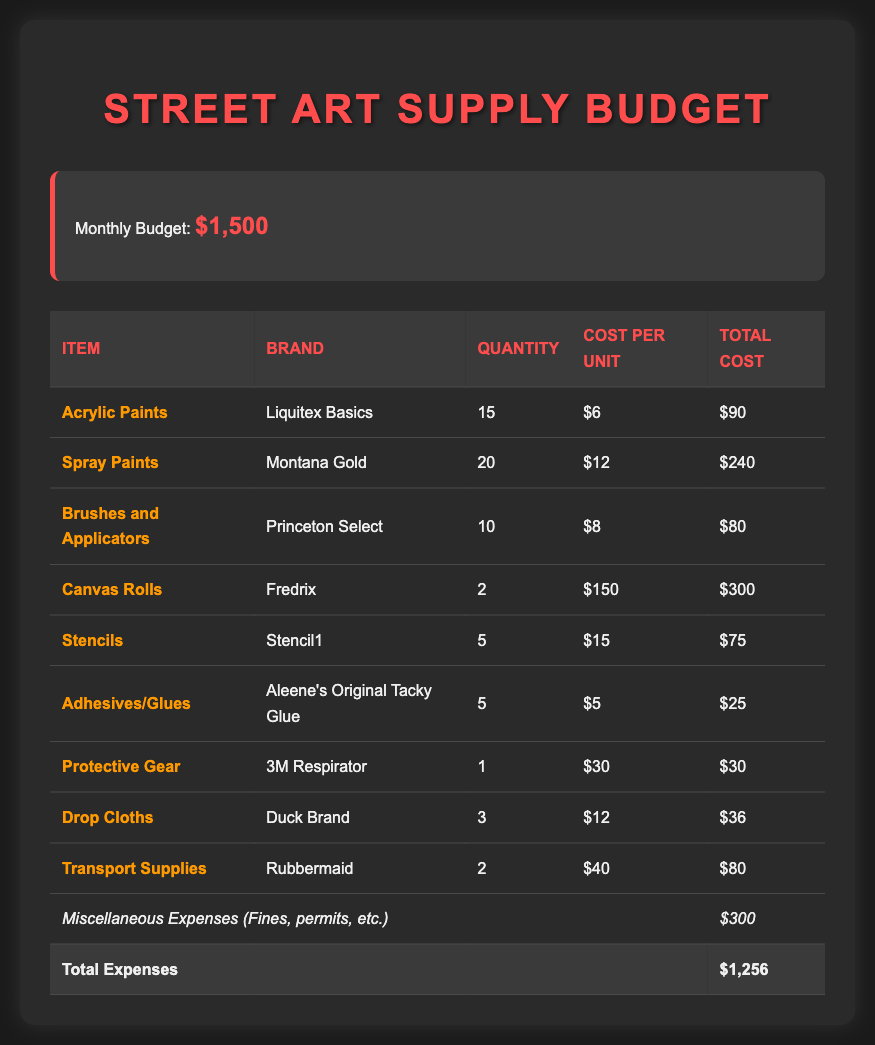what is the monthly budget? The monthly budget is stated at the beginning of the document, which is $1,500.
Answer: $1,500 how many spray paints are purchased? The quantity of spray paints is listed in the table under the quantity column, which is 20.
Answer: 20 what is the total cost for acrylic paints? The total cost for acrylic paints is provided in the last column of the table, which is $90.
Answer: $90 which brand is used for protective gear? The brand for protective gear is identified in the table under the brand column, which is 3M.
Answer: 3M how much is allocated for miscellaneous expenses? The miscellaneous expenses are specifically listed in the document, amounting to $300.
Answer: $300 what is the total expense for the supplies? The total expenses are calculated and displayed at the bottom of the table, which is $1,256.
Answer: $1,256 what item has the highest cost per unit? To determine this, we look for the item with the highest cost per unit in the cost per unit column; canvas rolls have the highest unit cost at $150.
Answer: Canvas Rolls how many different types of paint supplies are listed? The painting supplies listed include acrylic paints and spray paints, so there are 2 types.
Answer: 2 is the cost of brushes and applicators more or less than protective gear? To compare, brushes and applicators cost $80, while protective gear costs $30, so brushes and applicators are more expensive.
Answer: More 